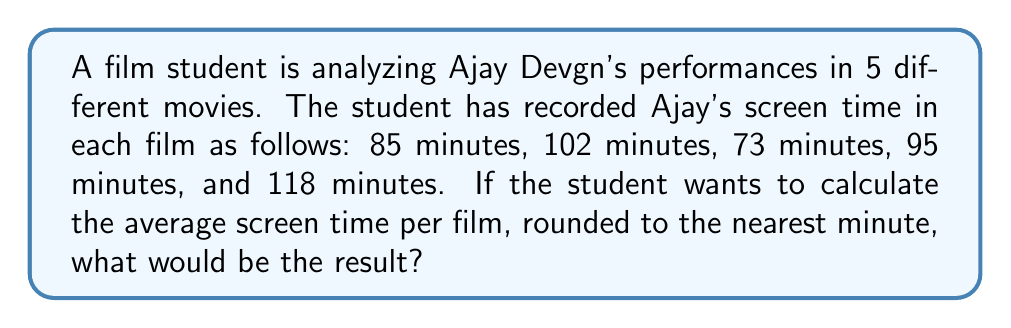Help me with this question. To solve this problem, we need to follow these steps:

1. Calculate the total screen time across all 5 films:
   $$85 + 102 + 73 + 95 + 118 = 473$$ minutes

2. Calculate the average screen time by dividing the total by the number of films:
   $$\frac{473}{5} = 94.6$$ minutes

3. Round the result to the nearest minute:
   94.6 rounds up to 95 minutes

Therefore, the average screen time of Ajay Devgn across these 5 films, rounded to the nearest minute, is 95 minutes.
Answer: 95 minutes 